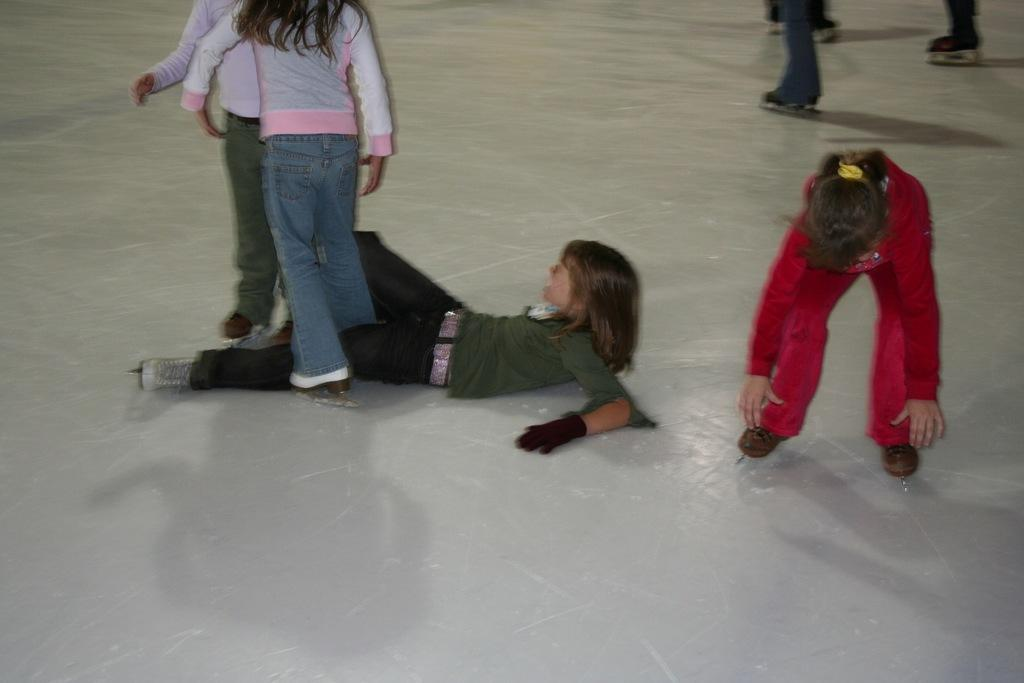How many people are in the image? There are people in the image. What is one person doing in the image? One person is lying on the floor. What is the answer to the riddle that is being told in the image? There is no riddle being told in the image, so it is not possible to answer that question. 